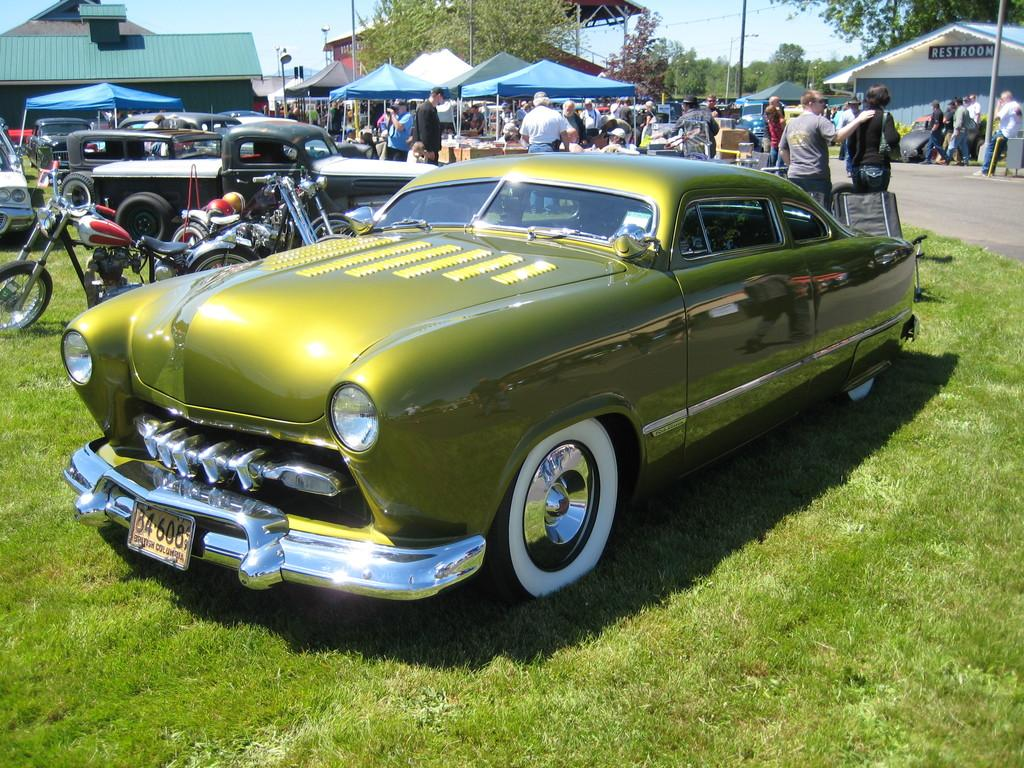What types of objects can be seen in the image? There are vehicles, people, stalls, buildings, poles, and other objects on the ground visible in the image. What is the primary surface on which the vehicles and people are moving? There is a road in the image on which the vehicles and people are moving. What type of vegetation is visible in the image? There is grass visible in the image. What is visible in the background of the image? The sky is visible in the background of the image. What advice is the person in the image giving to the vehicle? There is no interaction between the person and the vehicle in the image, so no advice is being given. How does the person in the image measure the distance between the stalls? There is no indication in the image that the person is measuring the distance between the stalls. 